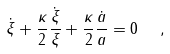<formula> <loc_0><loc_0><loc_500><loc_500>\dot { \xi } + \frac { \kappa } { 2 } \frac { \dot { \xi } } { \xi } + \frac { \kappa } { 2 } \frac { \dot { a } } { a } = 0 \ \ ,</formula> 